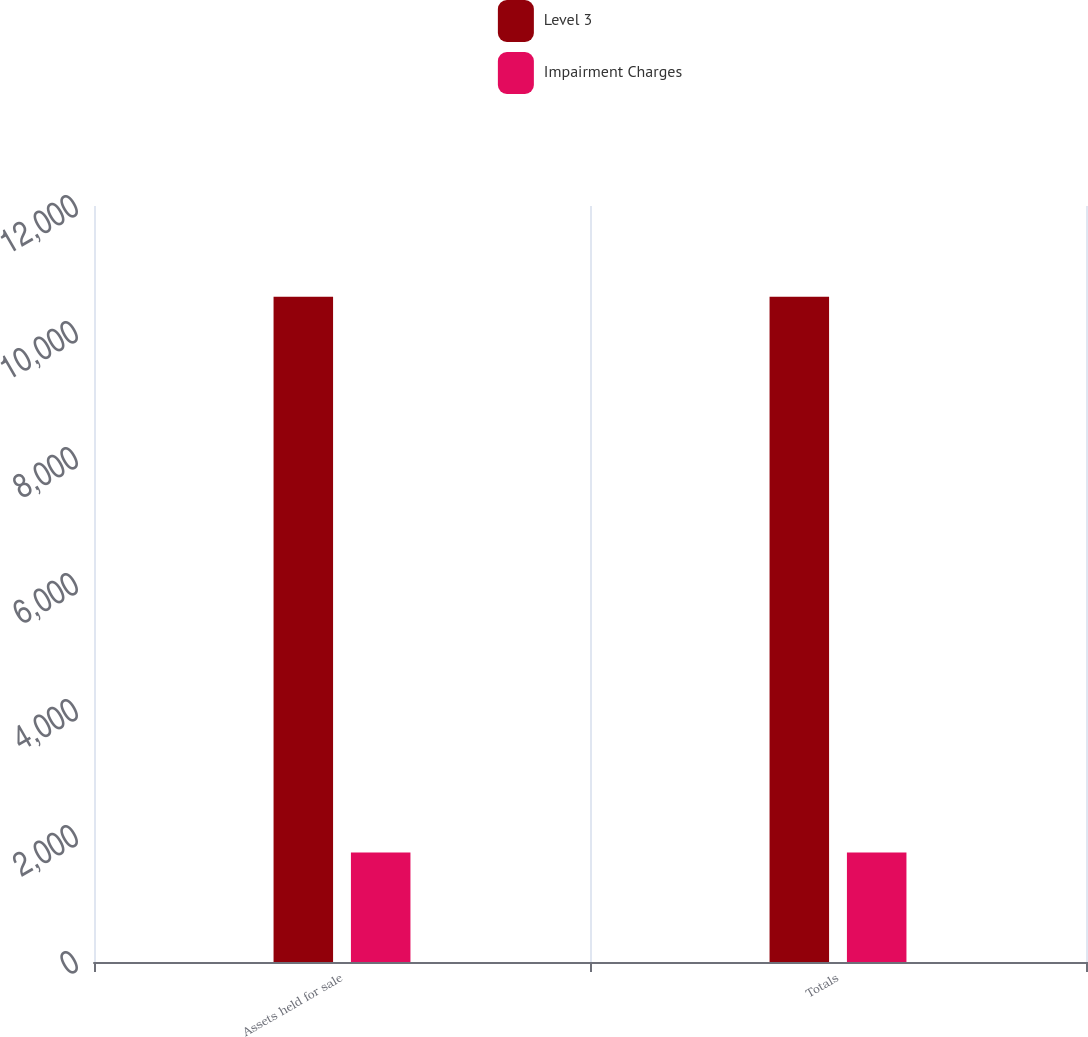Convert chart. <chart><loc_0><loc_0><loc_500><loc_500><stacked_bar_chart><ecel><fcel>Assets held for sale<fcel>Totals<nl><fcel>Level 3<fcel>10559<fcel>10559<nl><fcel>Impairment Charges<fcel>1738<fcel>1738<nl></chart> 